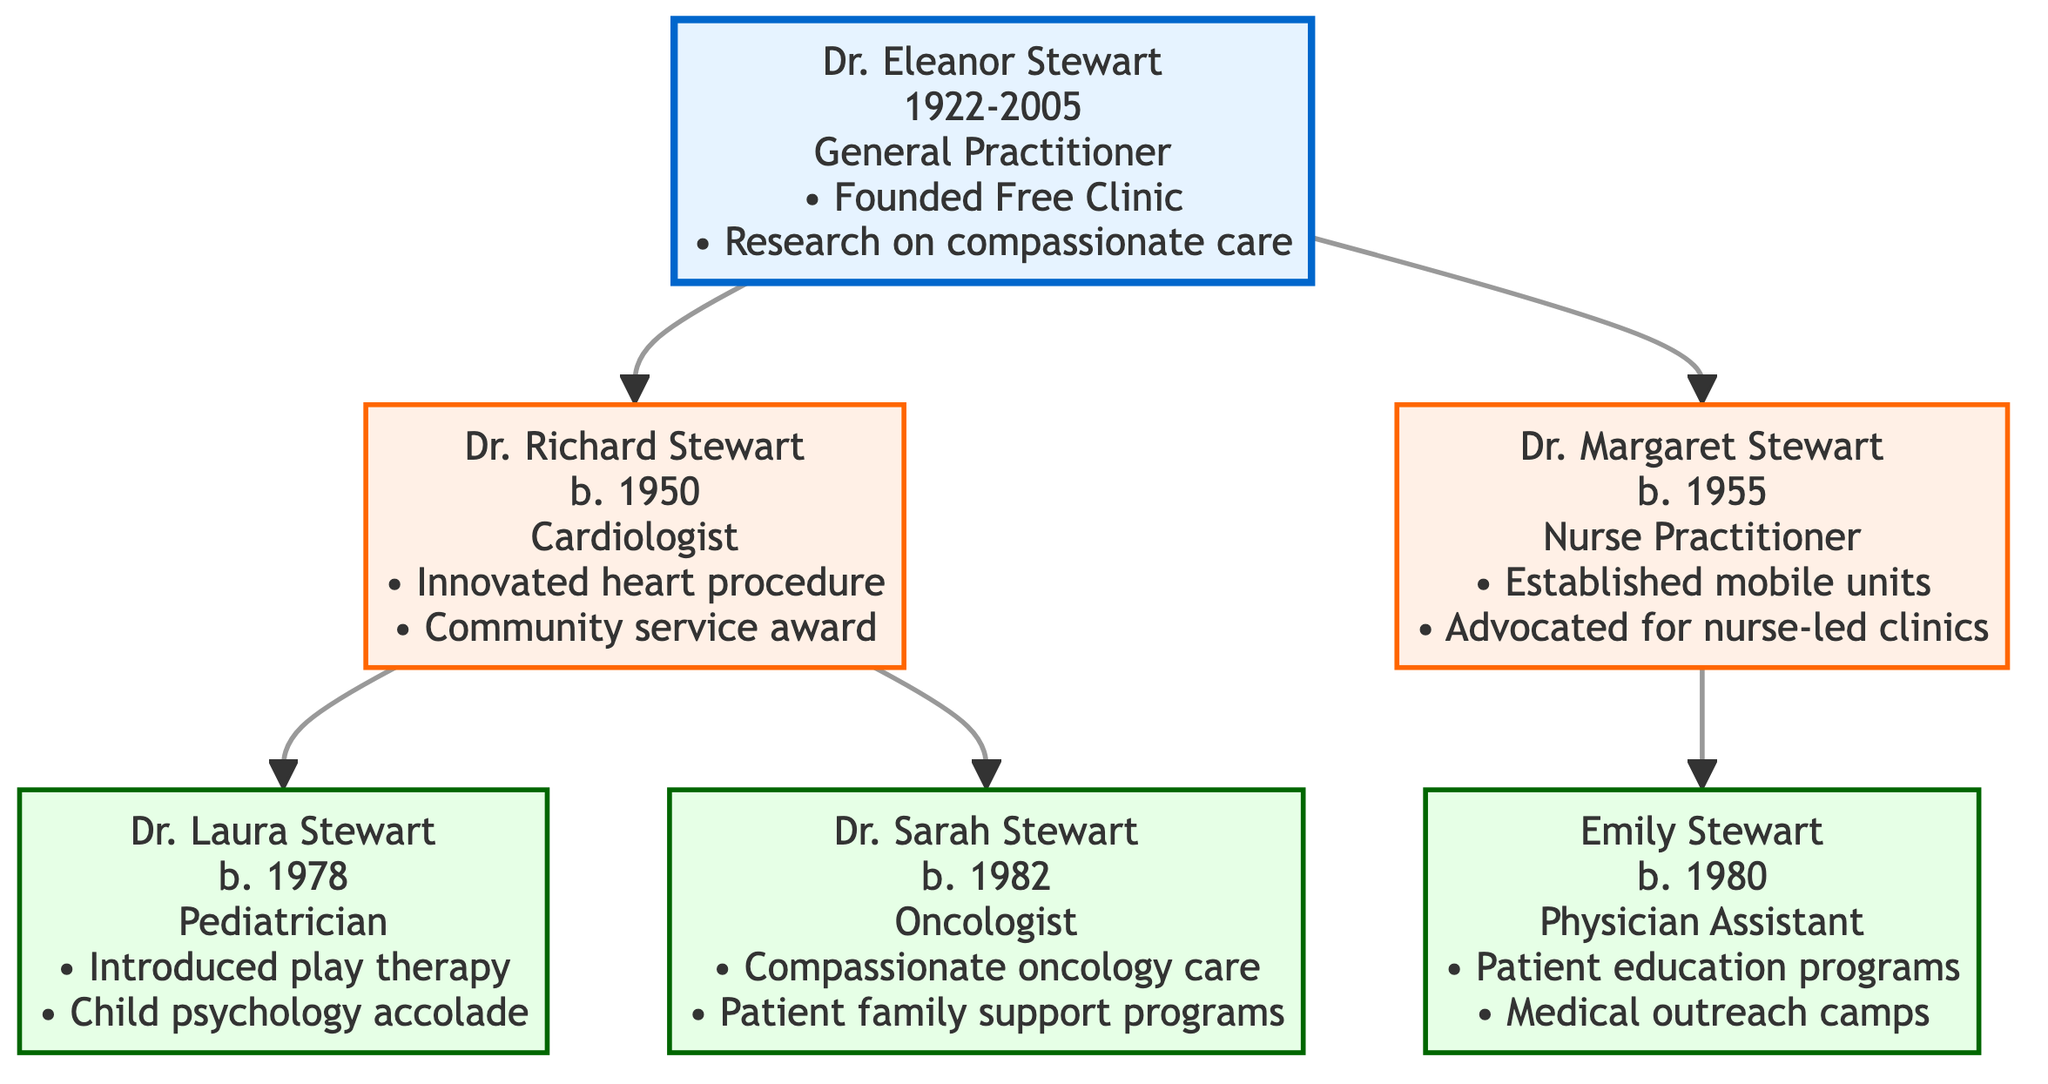What is the specialty of Dr. Richard Stewart? The diagram indicates that Dr. Richard Stewart specializes in cardiology, as noted next to his name.
Answer: Cardiologist How many children does Dr. Eleanor Stewart have? Looking at the diagram, Dr. Eleanor Stewart has two children: Dr. Richard Stewart and Dr. Margaret Stewart.
Answer: 2 Who is the mother of Emily Stewart? Tracing the family tree, Emily Stewart is indicated as the child of Dr. Margaret Stewart, making Dr. Margaret the mother of Emily.
Answer: Dr. Margaret Stewart What notable achievement is shared by both Dr. Laura Stewart and Dr. Sarah Stewart? Reviewing their notable achievements, both engaged in enhancing patient care with a focus on compassion; Laura introduced play therapy, and Sarah researched compassionate oncology care.
Answer: Compassionate care Which family member has focused on nurse-led clinics? In the diagram, Dr. Margaret Stewart is noted for advocating nurse-led clinics, specifying her focus in this area.
Answer: Dr. Margaret Stewart What year was Dr. Eleanor Stewart born? The diagram clearly states that Dr. Eleanor Stewart was born in the year 1922, provided directly beside her name.
Answer: 1922 How many oncologists are in the family tree? Examining the children of Dr. Richard Stewart, the diagram shows that only Dr. Sarah Stewart is an oncologist, indicating there is one oncologist in the family tree.
Answer: 1 Which generation does Emily Stewart belong to in the family tree? The family tree structure shows that Emily Stewart is a child of Dr. Margaret Stewart, placing her in the third generation.
Answer: Third generation What is the field of specialty for Dr. Laura Stewart? According to the diagram, Dr. Laura Stewart is identified as a pediatrician, cited next to her name.
Answer: Pediatrician 